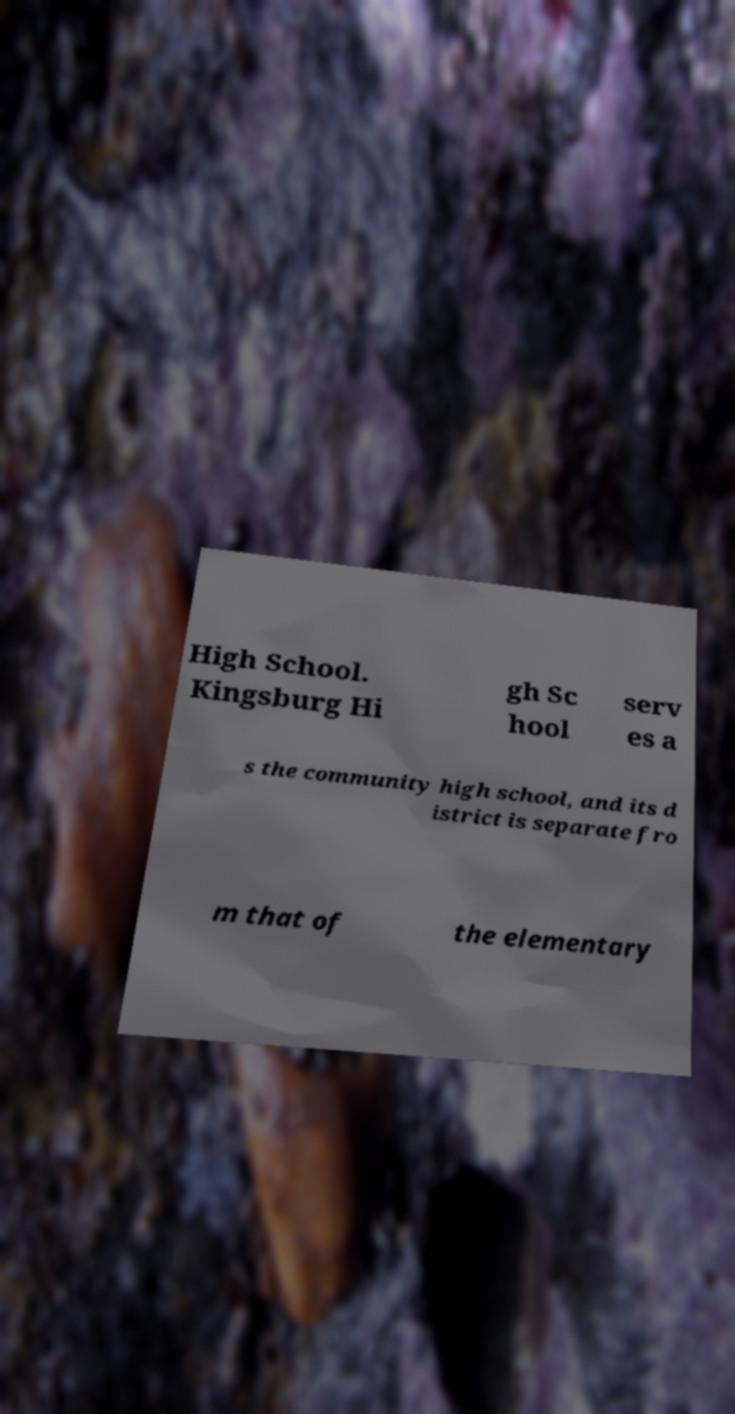Please read and relay the text visible in this image. What does it say? High School. Kingsburg Hi gh Sc hool serv es a s the community high school, and its d istrict is separate fro m that of the elementary 